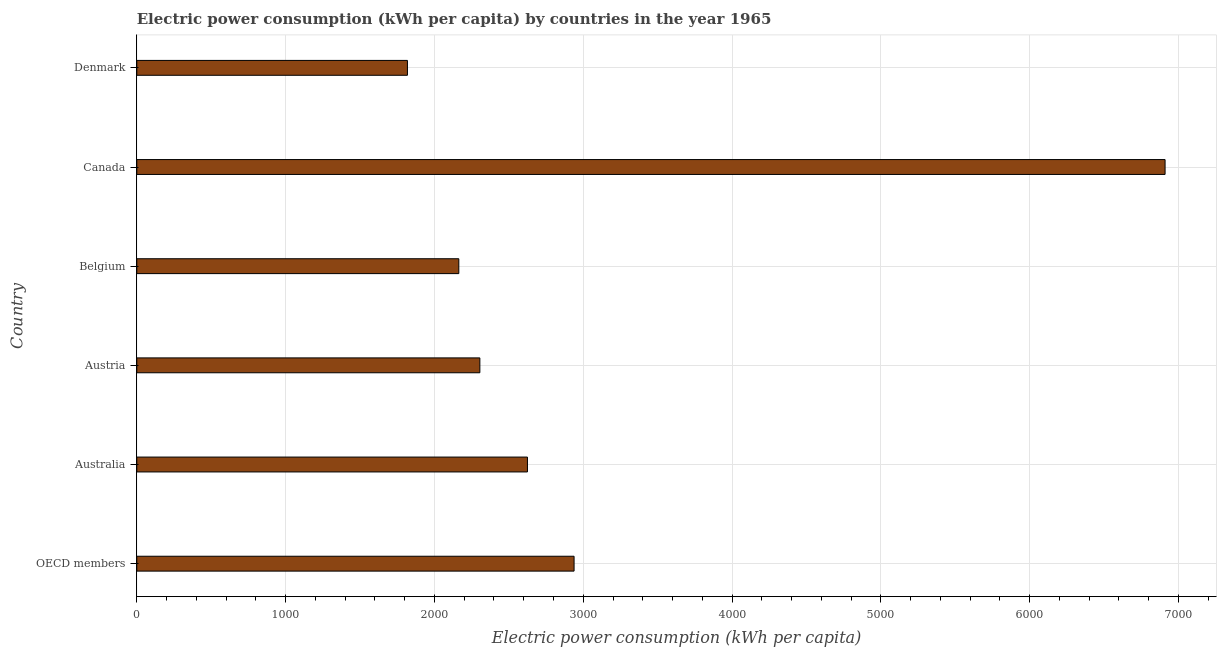Does the graph contain grids?
Your response must be concise. Yes. What is the title of the graph?
Give a very brief answer. Electric power consumption (kWh per capita) by countries in the year 1965. What is the label or title of the X-axis?
Offer a terse response. Electric power consumption (kWh per capita). What is the electric power consumption in Belgium?
Your answer should be compact. 2163.96. Across all countries, what is the maximum electric power consumption?
Ensure brevity in your answer.  6909.9. Across all countries, what is the minimum electric power consumption?
Your response must be concise. 1818.65. In which country was the electric power consumption maximum?
Offer a terse response. Canada. What is the sum of the electric power consumption?
Offer a terse response. 1.88e+04. What is the difference between the electric power consumption in Austria and OECD members?
Provide a succinct answer. -633.09. What is the average electric power consumption per country?
Keep it short and to the point. 3126.92. What is the median electric power consumption?
Offer a terse response. 2465.29. What is the ratio of the electric power consumption in Australia to that in Belgium?
Your response must be concise. 1.21. What is the difference between the highest and the second highest electric power consumption?
Provide a short and direct response. 3971.45. What is the difference between the highest and the lowest electric power consumption?
Ensure brevity in your answer.  5091.24. What is the difference between two consecutive major ticks on the X-axis?
Make the answer very short. 1000. What is the Electric power consumption (kWh per capita) of OECD members?
Your answer should be compact. 2938.44. What is the Electric power consumption (kWh per capita) in Australia?
Make the answer very short. 2625.22. What is the Electric power consumption (kWh per capita) in Austria?
Your answer should be compact. 2305.36. What is the Electric power consumption (kWh per capita) of Belgium?
Keep it short and to the point. 2163.96. What is the Electric power consumption (kWh per capita) of Canada?
Your answer should be very brief. 6909.9. What is the Electric power consumption (kWh per capita) in Denmark?
Your response must be concise. 1818.65. What is the difference between the Electric power consumption (kWh per capita) in OECD members and Australia?
Your answer should be compact. 313.22. What is the difference between the Electric power consumption (kWh per capita) in OECD members and Austria?
Your answer should be very brief. 633.09. What is the difference between the Electric power consumption (kWh per capita) in OECD members and Belgium?
Keep it short and to the point. 774.48. What is the difference between the Electric power consumption (kWh per capita) in OECD members and Canada?
Offer a very short reply. -3971.46. What is the difference between the Electric power consumption (kWh per capita) in OECD members and Denmark?
Ensure brevity in your answer.  1119.79. What is the difference between the Electric power consumption (kWh per capita) in Australia and Austria?
Give a very brief answer. 319.86. What is the difference between the Electric power consumption (kWh per capita) in Australia and Belgium?
Give a very brief answer. 461.26. What is the difference between the Electric power consumption (kWh per capita) in Australia and Canada?
Your answer should be compact. -4284.68. What is the difference between the Electric power consumption (kWh per capita) in Australia and Denmark?
Keep it short and to the point. 806.56. What is the difference between the Electric power consumption (kWh per capita) in Austria and Belgium?
Give a very brief answer. 141.4. What is the difference between the Electric power consumption (kWh per capita) in Austria and Canada?
Give a very brief answer. -4604.54. What is the difference between the Electric power consumption (kWh per capita) in Austria and Denmark?
Your answer should be very brief. 486.7. What is the difference between the Electric power consumption (kWh per capita) in Belgium and Canada?
Offer a terse response. -4745.94. What is the difference between the Electric power consumption (kWh per capita) in Belgium and Denmark?
Your response must be concise. 345.31. What is the difference between the Electric power consumption (kWh per capita) in Canada and Denmark?
Provide a succinct answer. 5091.24. What is the ratio of the Electric power consumption (kWh per capita) in OECD members to that in Australia?
Keep it short and to the point. 1.12. What is the ratio of the Electric power consumption (kWh per capita) in OECD members to that in Austria?
Offer a terse response. 1.27. What is the ratio of the Electric power consumption (kWh per capita) in OECD members to that in Belgium?
Offer a very short reply. 1.36. What is the ratio of the Electric power consumption (kWh per capita) in OECD members to that in Canada?
Your answer should be very brief. 0.42. What is the ratio of the Electric power consumption (kWh per capita) in OECD members to that in Denmark?
Your answer should be very brief. 1.62. What is the ratio of the Electric power consumption (kWh per capita) in Australia to that in Austria?
Make the answer very short. 1.14. What is the ratio of the Electric power consumption (kWh per capita) in Australia to that in Belgium?
Provide a short and direct response. 1.21. What is the ratio of the Electric power consumption (kWh per capita) in Australia to that in Canada?
Provide a succinct answer. 0.38. What is the ratio of the Electric power consumption (kWh per capita) in Australia to that in Denmark?
Offer a very short reply. 1.44. What is the ratio of the Electric power consumption (kWh per capita) in Austria to that in Belgium?
Provide a short and direct response. 1.06. What is the ratio of the Electric power consumption (kWh per capita) in Austria to that in Canada?
Provide a short and direct response. 0.33. What is the ratio of the Electric power consumption (kWh per capita) in Austria to that in Denmark?
Give a very brief answer. 1.27. What is the ratio of the Electric power consumption (kWh per capita) in Belgium to that in Canada?
Offer a terse response. 0.31. What is the ratio of the Electric power consumption (kWh per capita) in Belgium to that in Denmark?
Provide a short and direct response. 1.19. What is the ratio of the Electric power consumption (kWh per capita) in Canada to that in Denmark?
Your answer should be compact. 3.8. 